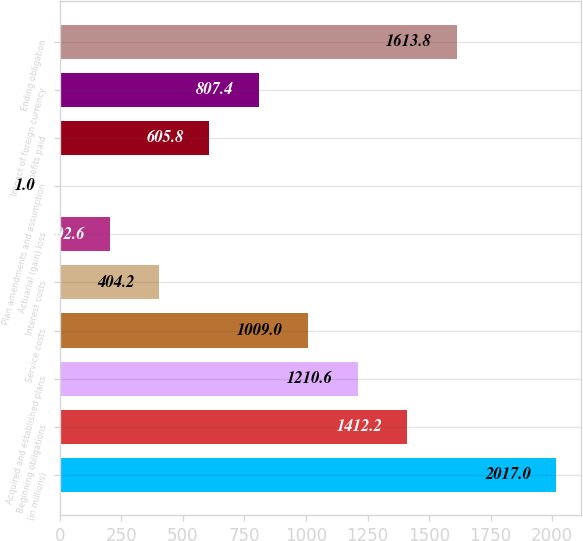Convert chart. <chart><loc_0><loc_0><loc_500><loc_500><bar_chart><fcel>(in millions)<fcel>Beginning obligations<fcel>Acquired and established plans<fcel>Service costs<fcel>Interest costs<fcel>Actuarial (gain) loss<fcel>Plan amendments and assumption<fcel>Benefits paid<fcel>Impact of foreign currency<fcel>Ending obligation<nl><fcel>2017<fcel>1412.2<fcel>1210.6<fcel>1009<fcel>404.2<fcel>202.6<fcel>1<fcel>605.8<fcel>807.4<fcel>1613.8<nl></chart> 